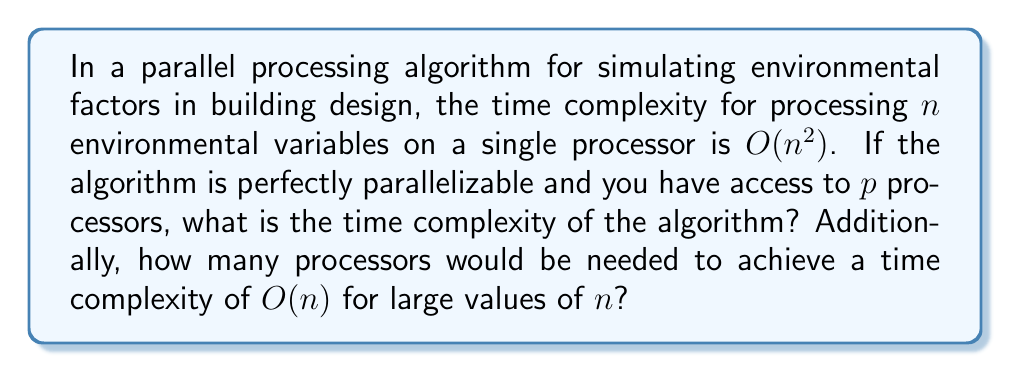What is the answer to this math problem? To solve this problem, we need to understand how parallel processing affects time complexity:

1. Single processor time complexity: $O(n^2)$

2. With $p$ processors, the work can be divided equally among them. The time complexity becomes:

   $$T(n,p) = O(\frac{n^2}{p})$$

3. To find the number of processors needed for $O(n)$ complexity:

   $$O(\frac{n^2}{p}) = O(n)$$

   $$\frac{n^2}{p} = n$$

   $$p = n$$

4. This means we need $n$ processors to achieve $O(n)$ time complexity.

5. However, it's important to note that this is theoretical. In practice, there are limits to how many processors can be effectively utilized due to communication overhead and Amdahl's Law.

6. The scalability of this algorithm is linear with respect to the number of processors, up to $n$ processors. Beyond that, adding more processors won't improve performance significantly.
Answer: The time complexity with $p$ processors is $O(\frac{n^2}{p})$. To achieve a time complexity of $O(n)$ for large values of $n$, theoretically $n$ processors would be needed. 